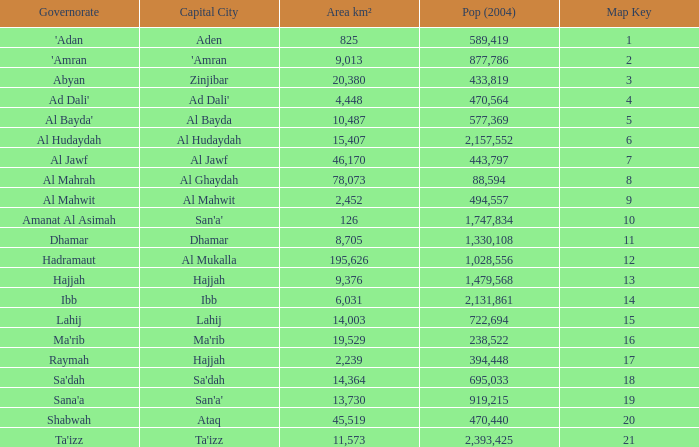Count the sum of Pop (2004) which has a Governorate of al mahrah with an Area km² smaller than 78,073? None. 